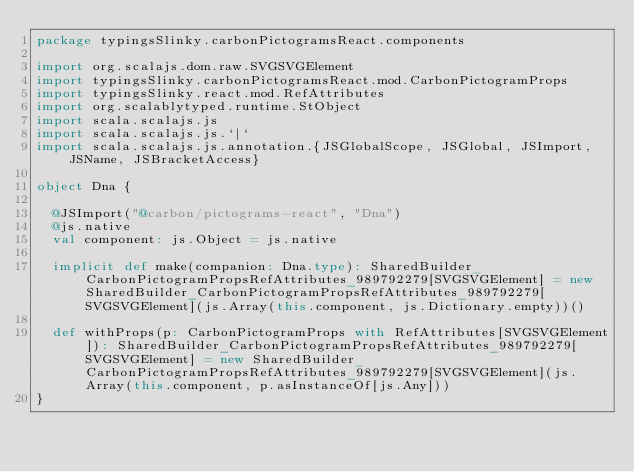<code> <loc_0><loc_0><loc_500><loc_500><_Scala_>package typingsSlinky.carbonPictogramsReact.components

import org.scalajs.dom.raw.SVGSVGElement
import typingsSlinky.carbonPictogramsReact.mod.CarbonPictogramProps
import typingsSlinky.react.mod.RefAttributes
import org.scalablytyped.runtime.StObject
import scala.scalajs.js
import scala.scalajs.js.`|`
import scala.scalajs.js.annotation.{JSGlobalScope, JSGlobal, JSImport, JSName, JSBracketAccess}

object Dna {
  
  @JSImport("@carbon/pictograms-react", "Dna")
  @js.native
  val component: js.Object = js.native
  
  implicit def make(companion: Dna.type): SharedBuilder_CarbonPictogramPropsRefAttributes_989792279[SVGSVGElement] = new SharedBuilder_CarbonPictogramPropsRefAttributes_989792279[SVGSVGElement](js.Array(this.component, js.Dictionary.empty))()
  
  def withProps(p: CarbonPictogramProps with RefAttributes[SVGSVGElement]): SharedBuilder_CarbonPictogramPropsRefAttributes_989792279[SVGSVGElement] = new SharedBuilder_CarbonPictogramPropsRefAttributes_989792279[SVGSVGElement](js.Array(this.component, p.asInstanceOf[js.Any]))
}
</code> 